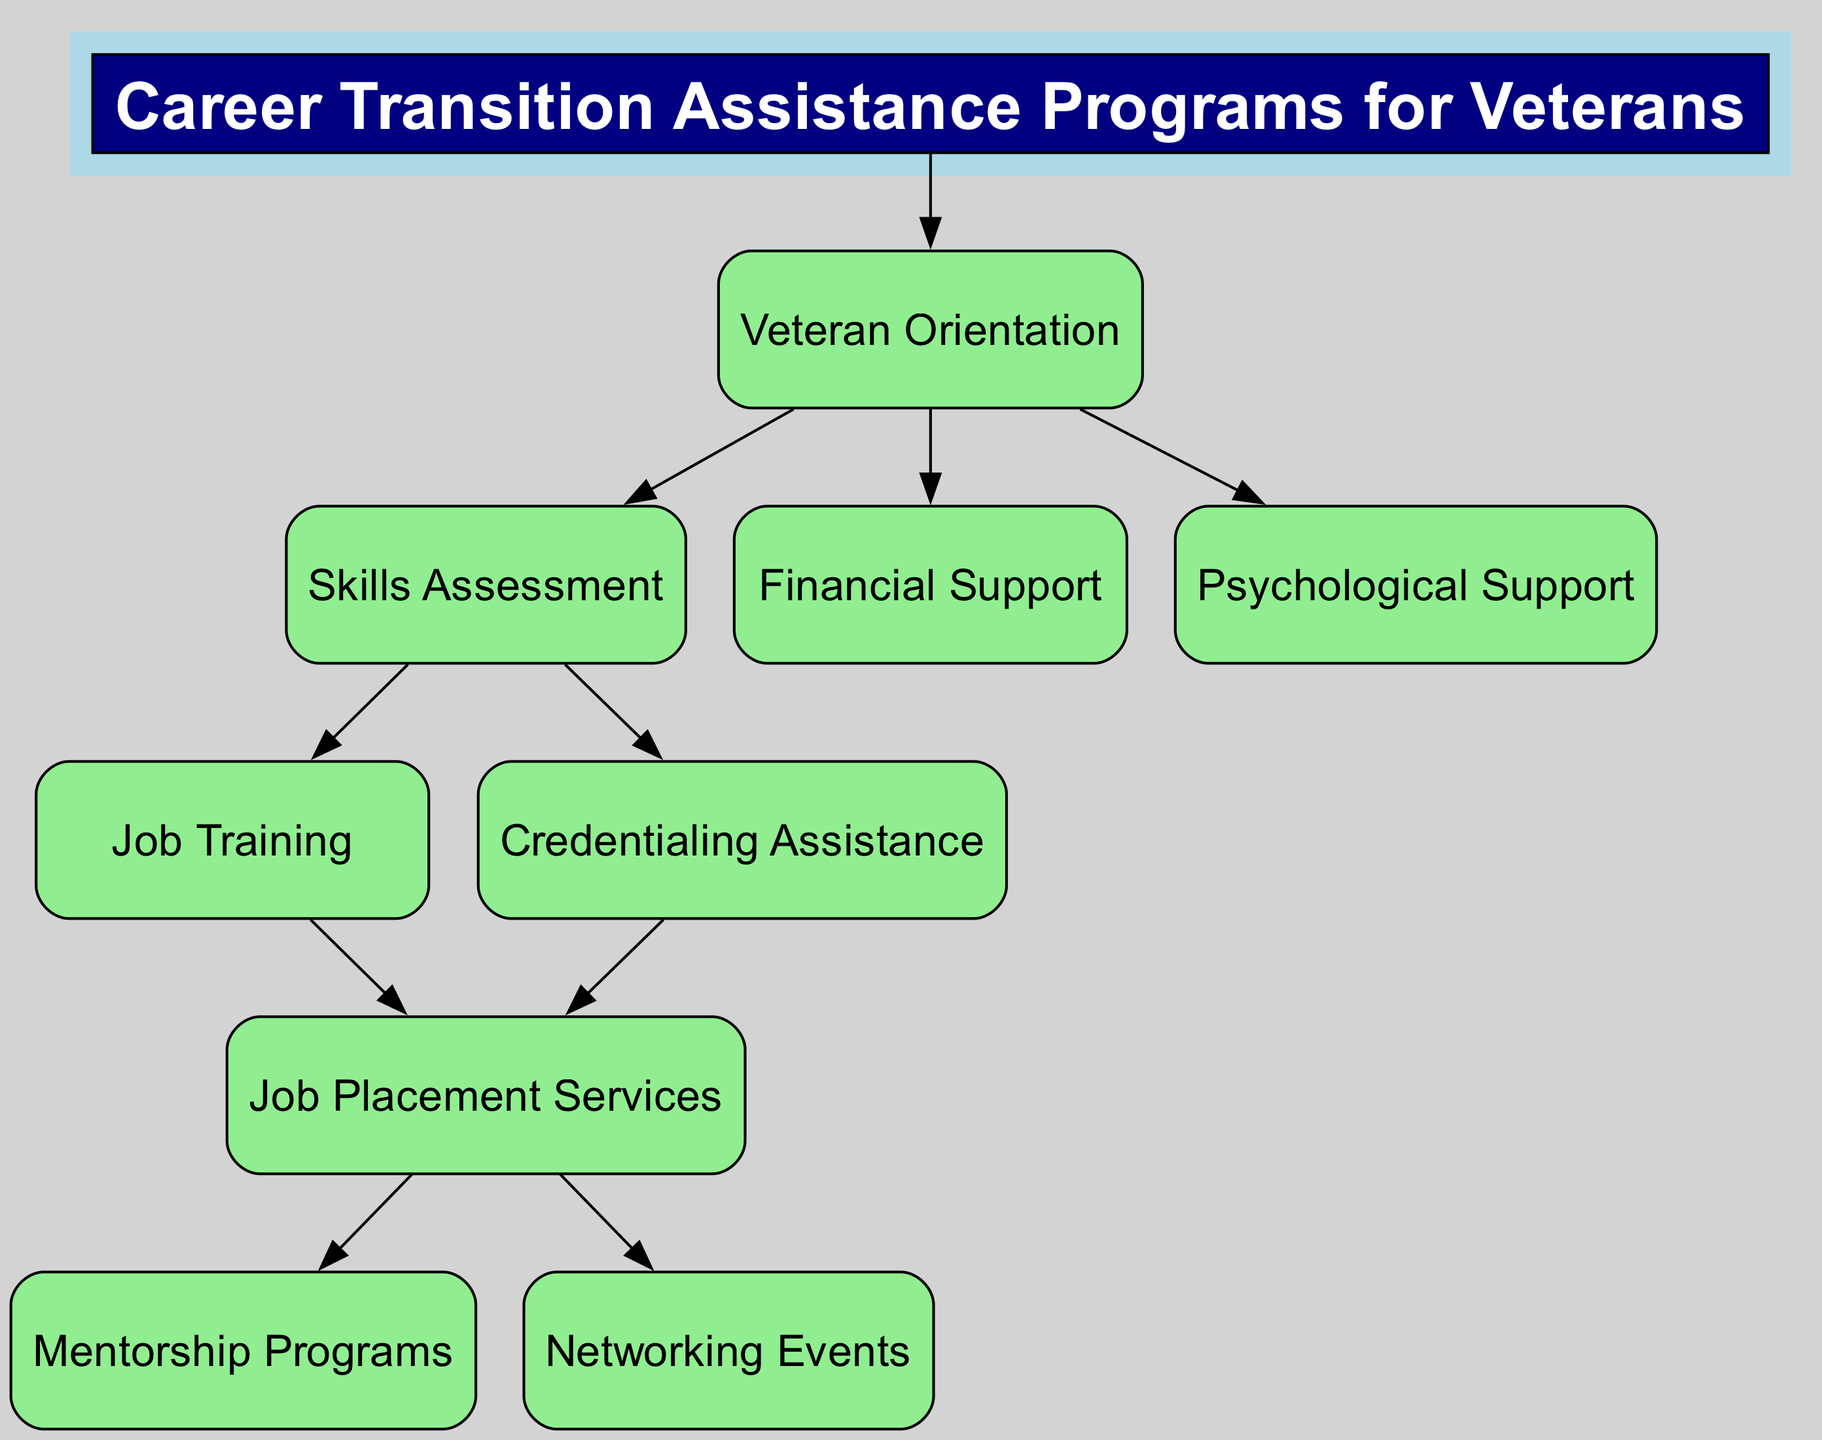What is the title of the diagram? The title is stated at the top of the diagram within a filled rectangle, and it represents the main topic of the block diagram. It identifies the overall focus of the content being presented.
Answer: Career Transition Assistance Programs for Veterans How many main program categories are shown in the diagram? Each node excluding the title represents a main program, and by counting each of these nodes from 'Veteran Orientation' to 'Psychological Support', we find the total count. There are ten nodes in total.
Answer: Ten What is the first program listed after the introduction? The first program is identified as the immediate next node after the title in the flow of the diagram, indicating the initial support available to veterans.
Answer: Veteran Orientation Which program connects to both 'Job Training' and 'Credentialing Assistance'? This involves understanding the flow from the 'Skills Assessment' node, as it directly branches into 'Job Training' and 'Credentialing Assistance' according to the diagram's structure.
Answer: Skills Assessment Which program provides financial aid? By following the connections from the 'Veteran Orientation' node, it becomes clear that this program is specifically aimed at offering financial support to assist veterans during transition.
Answer: Financial Support What type of support does the 'Psychological Support' program provide? This program focuses on a specific aspect of veterans' needs, which is mental health support and counseling, addressing the psychological challenges that may arise during transition.
Answer: Counseling and mental health services What is the last program listed in the diagram? The last program can be found by noting the flow of connections from the 'Job Placement Services', which branches out to 'Mentorship Programs' and 'Networking Events', leading us to the final node in the sequence.
Answer: Networking Events How does 'Job Placement Services' relate to 'Mentorship Programs'? This connection is made clear in the diagram, as 'Job Placement Services' is a preceding node directly leading into 'Mentorship Programs', establishing a supportive relationship for veterans seeking jobs.
Answer: Direct connection What type of events are organized to build professional networks? This relates to a specific node that categorizes the events tailored for networking purposes, aimed at facilitating connections between veterans and potential employers.
Answer: Networking Events 